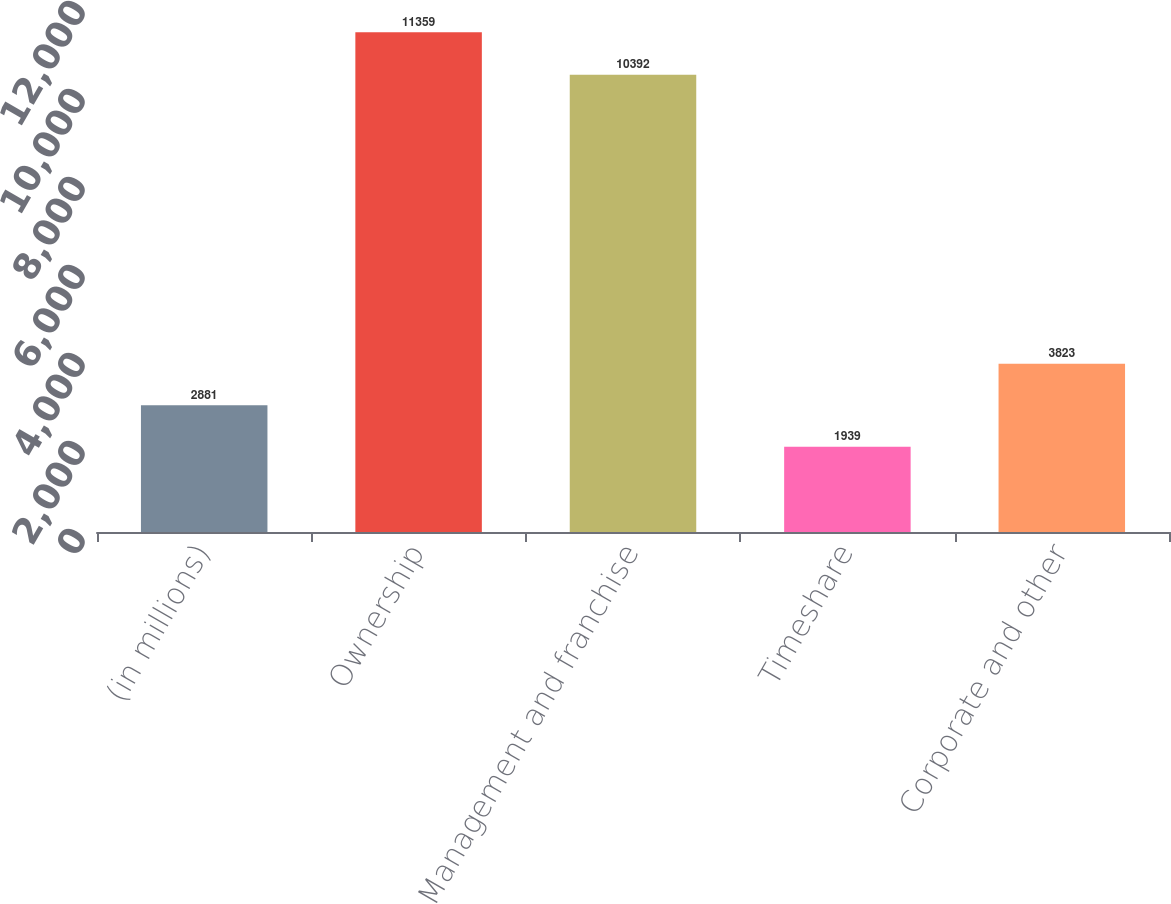Convert chart to OTSL. <chart><loc_0><loc_0><loc_500><loc_500><bar_chart><fcel>(in millions)<fcel>Ownership<fcel>Management and franchise<fcel>Timeshare<fcel>Corporate and other<nl><fcel>2881<fcel>11359<fcel>10392<fcel>1939<fcel>3823<nl></chart> 